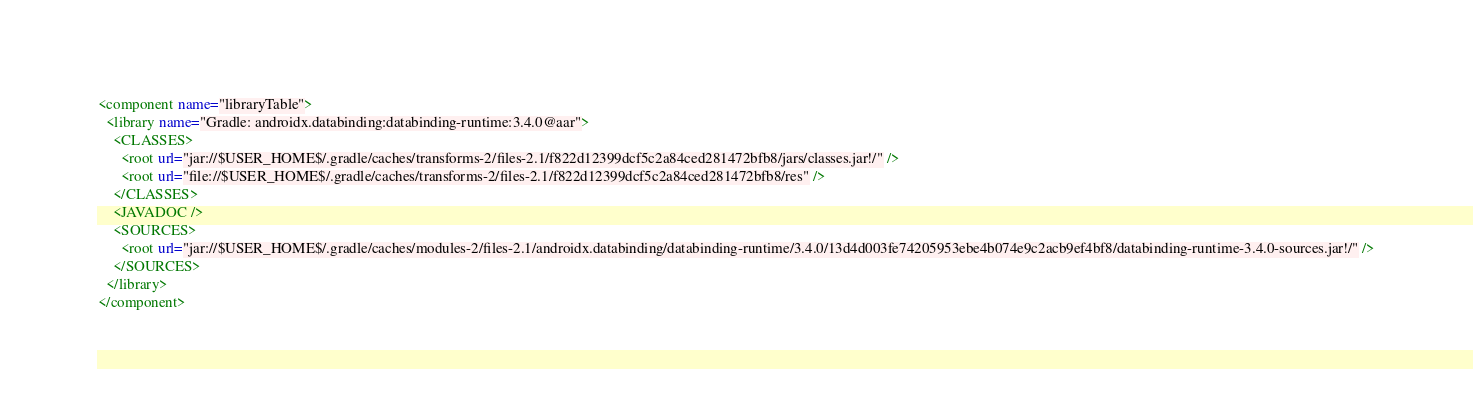Convert code to text. <code><loc_0><loc_0><loc_500><loc_500><_XML_><component name="libraryTable">
  <library name="Gradle: androidx.databinding:databinding-runtime:3.4.0@aar">
    <CLASSES>
      <root url="jar://$USER_HOME$/.gradle/caches/transforms-2/files-2.1/f822d12399dcf5c2a84ced281472bfb8/jars/classes.jar!/" />
      <root url="file://$USER_HOME$/.gradle/caches/transforms-2/files-2.1/f822d12399dcf5c2a84ced281472bfb8/res" />
    </CLASSES>
    <JAVADOC />
    <SOURCES>
      <root url="jar://$USER_HOME$/.gradle/caches/modules-2/files-2.1/androidx.databinding/databinding-runtime/3.4.0/13d4d003fe74205953ebe4b074e9c2acb9ef4bf8/databinding-runtime-3.4.0-sources.jar!/" />
    </SOURCES>
  </library>
</component></code> 